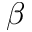Convert formula to latex. <formula><loc_0><loc_0><loc_500><loc_500>\beta</formula> 